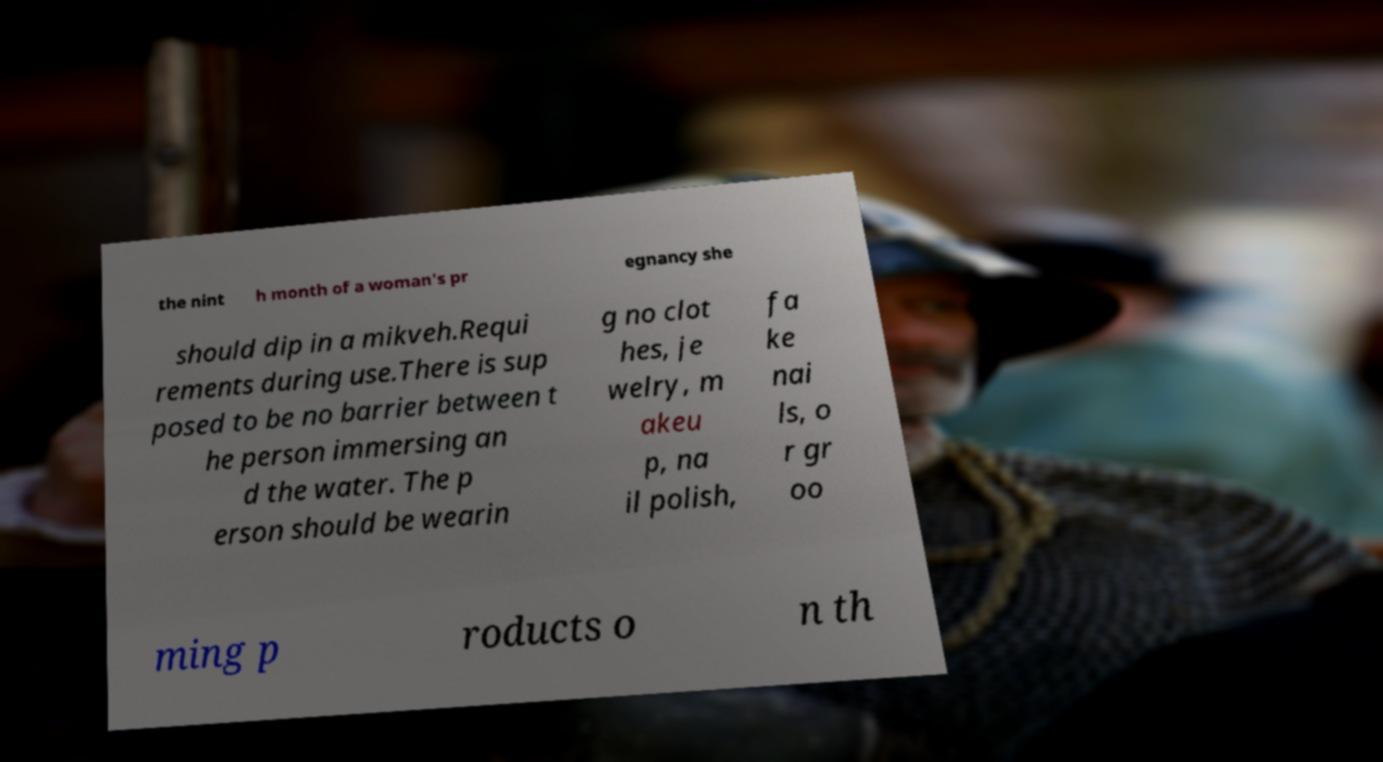What messages or text are displayed in this image? I need them in a readable, typed format. the nint h month of a woman's pr egnancy she should dip in a mikveh.Requi rements during use.There is sup posed to be no barrier between t he person immersing an d the water. The p erson should be wearin g no clot hes, je welry, m akeu p, na il polish, fa ke nai ls, o r gr oo ming p roducts o n th 